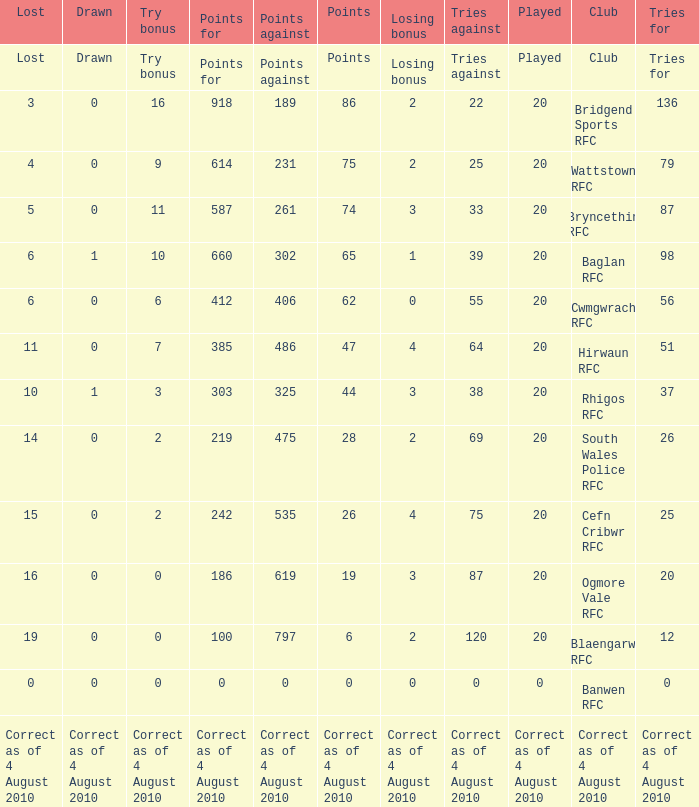What is the points against when drawn is drawn? Points against. 